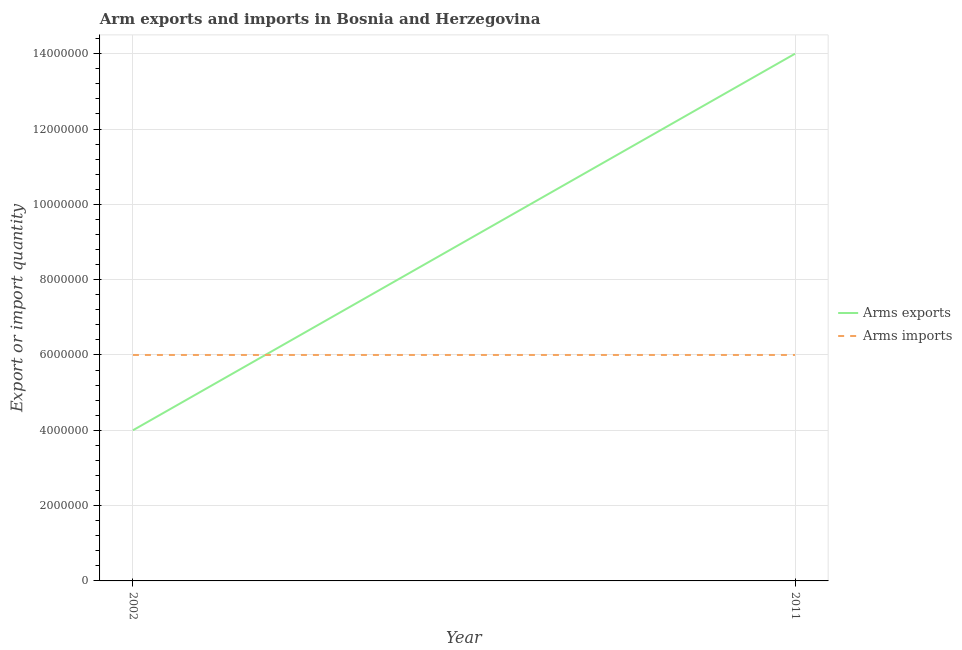Does the line corresponding to arms exports intersect with the line corresponding to arms imports?
Provide a succinct answer. Yes. Is the number of lines equal to the number of legend labels?
Provide a succinct answer. Yes. What is the arms exports in 2002?
Your answer should be very brief. 4.00e+06. Across all years, what is the maximum arms exports?
Offer a very short reply. 1.40e+07. Across all years, what is the minimum arms imports?
Provide a succinct answer. 6.00e+06. In which year was the arms imports minimum?
Keep it short and to the point. 2002. What is the total arms imports in the graph?
Make the answer very short. 1.20e+07. What is the difference between the arms imports in 2002 and that in 2011?
Offer a very short reply. 0. What is the difference between the arms exports in 2002 and the arms imports in 2011?
Offer a terse response. -2.00e+06. What is the average arms exports per year?
Give a very brief answer. 9.00e+06. In the year 2011, what is the difference between the arms exports and arms imports?
Make the answer very short. 8.00e+06. What is the ratio of the arms imports in 2002 to that in 2011?
Provide a short and direct response. 1. In how many years, is the arms exports greater than the average arms exports taken over all years?
Your response must be concise. 1. Is the arms exports strictly greater than the arms imports over the years?
Ensure brevity in your answer.  No. Is the arms exports strictly less than the arms imports over the years?
Offer a very short reply. No. How many lines are there?
Offer a very short reply. 2. How many years are there in the graph?
Your answer should be very brief. 2. What is the difference between two consecutive major ticks on the Y-axis?
Ensure brevity in your answer.  2.00e+06. Are the values on the major ticks of Y-axis written in scientific E-notation?
Make the answer very short. No. Does the graph contain grids?
Provide a short and direct response. Yes. What is the title of the graph?
Your answer should be compact. Arm exports and imports in Bosnia and Herzegovina. What is the label or title of the X-axis?
Your response must be concise. Year. What is the label or title of the Y-axis?
Keep it short and to the point. Export or import quantity. What is the Export or import quantity of Arms exports in 2002?
Your response must be concise. 4.00e+06. What is the Export or import quantity in Arms imports in 2002?
Make the answer very short. 6.00e+06. What is the Export or import quantity in Arms exports in 2011?
Make the answer very short. 1.40e+07. Across all years, what is the maximum Export or import quantity in Arms exports?
Offer a terse response. 1.40e+07. Across all years, what is the maximum Export or import quantity in Arms imports?
Offer a terse response. 6.00e+06. Across all years, what is the minimum Export or import quantity of Arms imports?
Give a very brief answer. 6.00e+06. What is the total Export or import quantity of Arms exports in the graph?
Your response must be concise. 1.80e+07. What is the total Export or import quantity of Arms imports in the graph?
Your answer should be very brief. 1.20e+07. What is the difference between the Export or import quantity in Arms exports in 2002 and that in 2011?
Your answer should be compact. -1.00e+07. What is the average Export or import quantity in Arms exports per year?
Your answer should be compact. 9.00e+06. In the year 2002, what is the difference between the Export or import quantity of Arms exports and Export or import quantity of Arms imports?
Offer a very short reply. -2.00e+06. In the year 2011, what is the difference between the Export or import quantity of Arms exports and Export or import quantity of Arms imports?
Offer a very short reply. 8.00e+06. What is the ratio of the Export or import quantity in Arms exports in 2002 to that in 2011?
Offer a very short reply. 0.29. What is the ratio of the Export or import quantity of Arms imports in 2002 to that in 2011?
Provide a short and direct response. 1. What is the difference between the highest and the second highest Export or import quantity in Arms imports?
Provide a succinct answer. 0. What is the difference between the highest and the lowest Export or import quantity in Arms exports?
Offer a very short reply. 1.00e+07. What is the difference between the highest and the lowest Export or import quantity in Arms imports?
Keep it short and to the point. 0. 